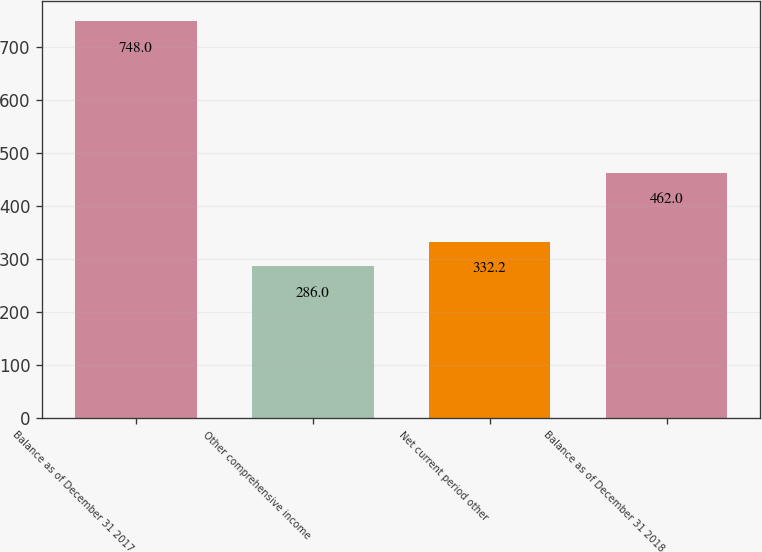<chart> <loc_0><loc_0><loc_500><loc_500><bar_chart><fcel>Balance as of December 31 2017<fcel>Other comprehensive income<fcel>Net current period other<fcel>Balance as of December 31 2018<nl><fcel>748<fcel>286<fcel>332.2<fcel>462<nl></chart> 